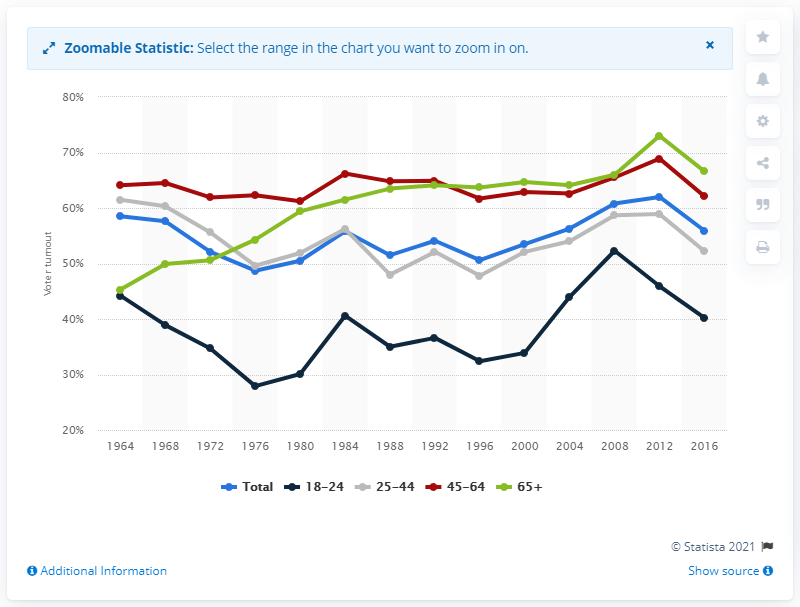Draw attention to some important aspects in this diagram. Older voters began pushing black voter turnout below the average in 1984. 